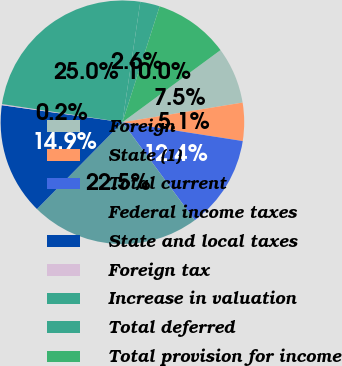Convert chart to OTSL. <chart><loc_0><loc_0><loc_500><loc_500><pie_chart><fcel>Foreign<fcel>State (1)<fcel>Total current<fcel>Federal income taxes<fcel>State and local taxes<fcel>Foreign tax<fcel>Increase in valuation<fcel>Total deferred<fcel>Total provision for income<nl><fcel>7.51%<fcel>5.05%<fcel>12.41%<fcel>22.5%<fcel>14.86%<fcel>0.15%<fcel>24.96%<fcel>2.6%<fcel>9.96%<nl></chart> 